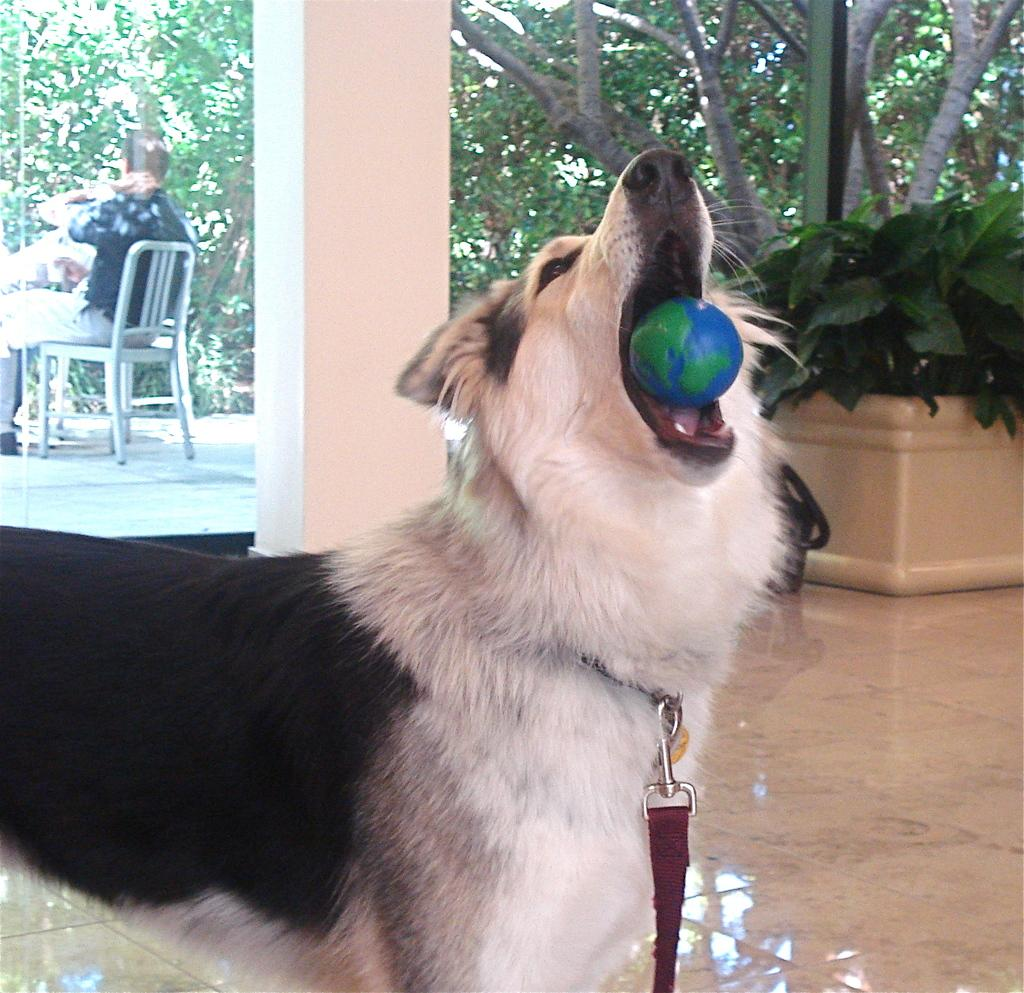What animal can be seen in the image? There is a dog in the image. What is the dog doing with its mouth? The dog is holding a ball in its mouth. What type of vegetation is visible in the image? There are trees visible in the image. What is the man in the image doing? The man is seated on a chair in the image. What type of insect can be seen flying around the man in the image? There are no insects visible in the image. What type of sport is the man playing with the dog in the image? The dog is holding a ball in its mouth, but there is no indication of a sport being played in the image. 